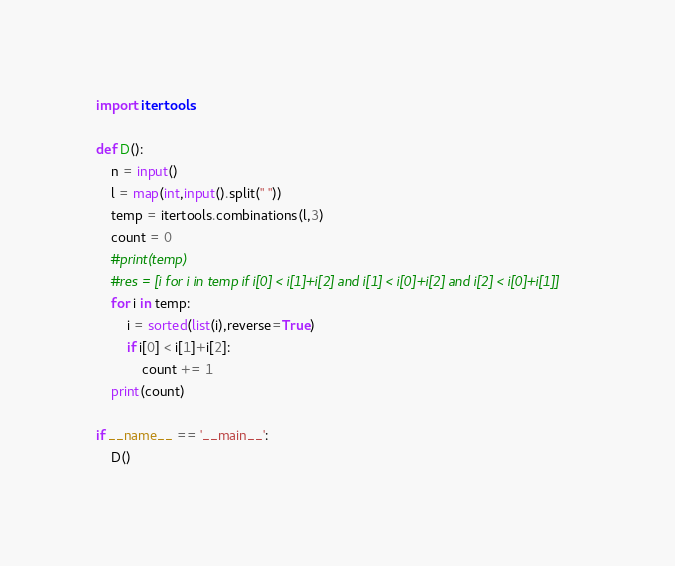<code> <loc_0><loc_0><loc_500><loc_500><_Python_>import itertools

def D():
    n = input()
    l = map(int,input().split(" "))
    temp = itertools.combinations(l,3)
    count = 0
    #print(temp)
    #res = [i for i in temp if i[0] < i[1]+i[2] and i[1] < i[0]+i[2] and i[2] < i[0]+i[1]]
    for i in temp:
        i = sorted(list(i),reverse=True)
        if i[0] < i[1]+i[2]:
            count += 1
    print(count)

if __name__ == '__main__':
    D()</code> 